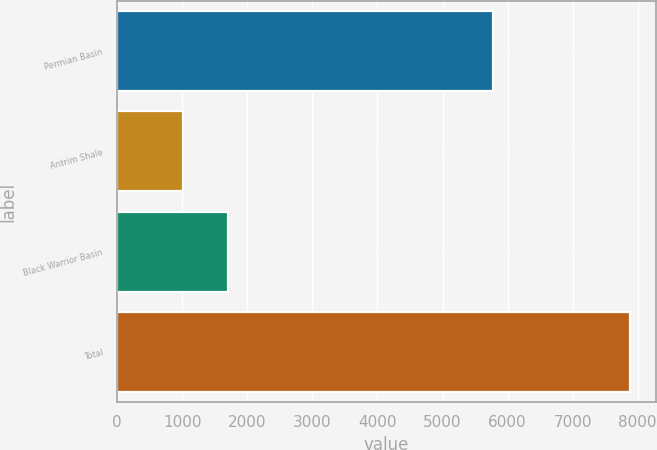Convert chart. <chart><loc_0><loc_0><loc_500><loc_500><bar_chart><fcel>Permian Basin<fcel>Antrim Shale<fcel>Black Warrior Basin<fcel>Total<nl><fcel>5773<fcel>1009<fcel>1696.3<fcel>7882<nl></chart> 